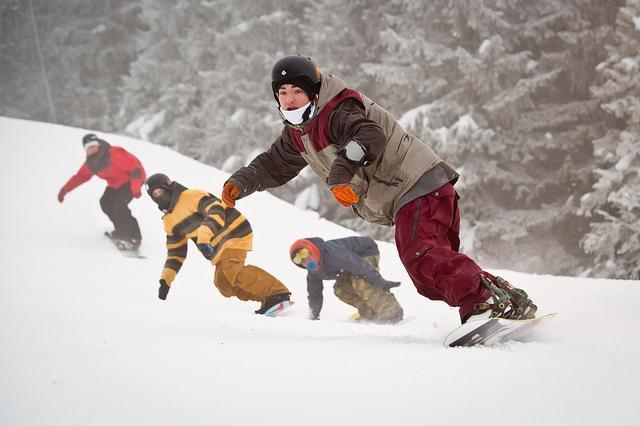How many people are visible?
Give a very brief answer. 4. 